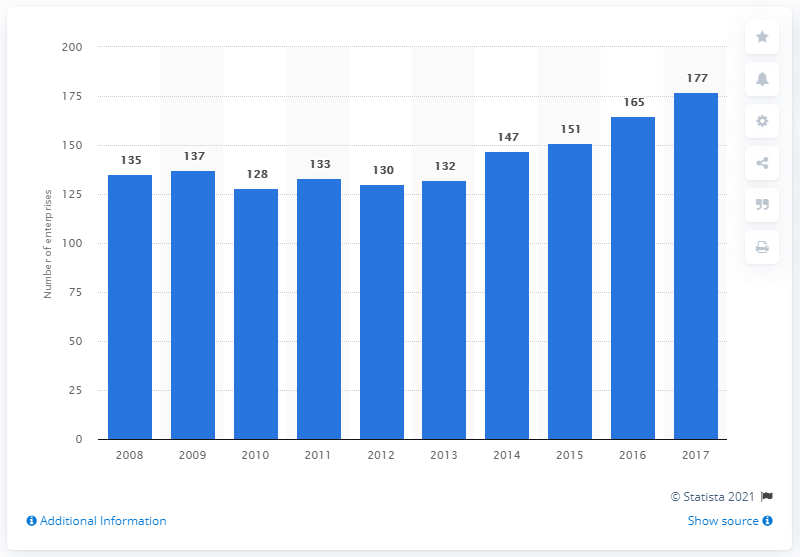List a handful of essential elements in this visual. In 2017, there were 177 enterprises in the cocoa, chocolate and sugar confectionery manufacturing sector in Portugal. 